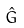Convert formula to latex. <formula><loc_0><loc_0><loc_500><loc_500>\hat { G }</formula> 